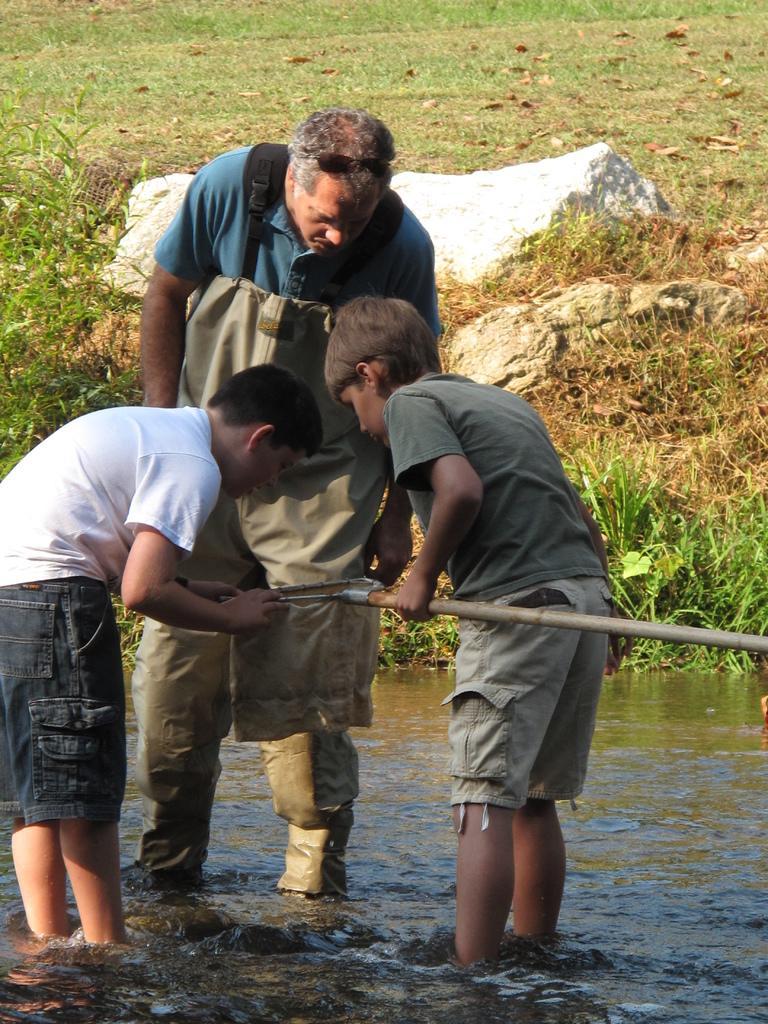Could you give a brief overview of what you see in this image? In this image there is a person and two kids are standing in the water, two kids are holding an object in their hand. In the background there are a few rocks on the surface of the grass. 